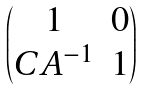Convert formula to latex. <formula><loc_0><loc_0><loc_500><loc_500>\begin{pmatrix} 1 & 0 \\ C A ^ { - 1 } & 1 \end{pmatrix}</formula> 